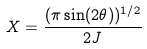Convert formula to latex. <formula><loc_0><loc_0><loc_500><loc_500>X = \frac { ( \pi \sin ( 2 \theta ) ) ^ { 1 / 2 } } { 2 J }</formula> 